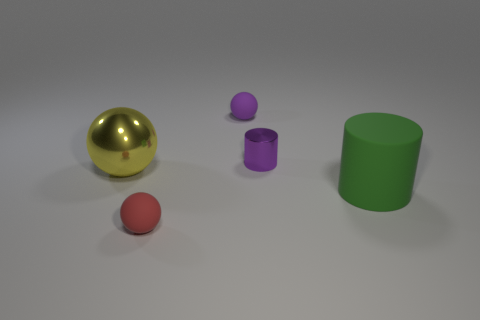Subtract all tiny spheres. How many spheres are left? 1 Add 1 yellow shiny objects. How many objects exist? 6 Subtract all yellow spheres. How many spheres are left? 2 Subtract all spheres. How many objects are left? 2 Subtract all red cylinders. How many red balls are left? 1 Subtract all tiny green rubber balls. Subtract all green objects. How many objects are left? 4 Add 4 large yellow shiny objects. How many large yellow shiny objects are left? 5 Add 2 purple metallic blocks. How many purple metallic blocks exist? 2 Subtract 0 gray cubes. How many objects are left? 5 Subtract 2 cylinders. How many cylinders are left? 0 